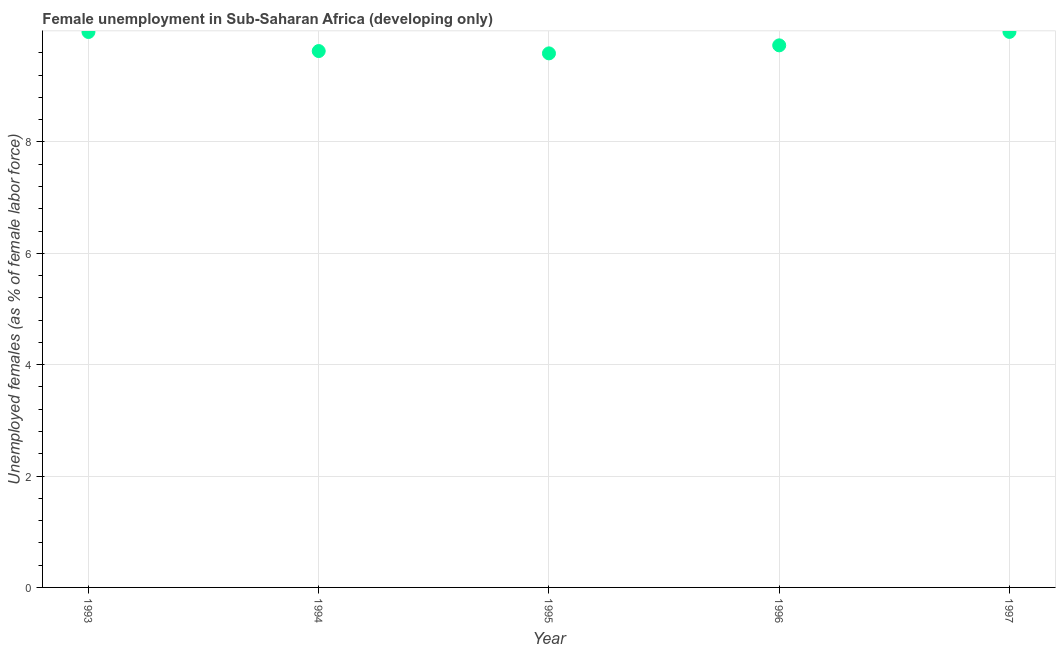What is the unemployed females population in 1993?
Your answer should be compact. 9.98. Across all years, what is the maximum unemployed females population?
Provide a short and direct response. 9.98. Across all years, what is the minimum unemployed females population?
Offer a terse response. 9.59. In which year was the unemployed females population maximum?
Give a very brief answer. 1997. What is the sum of the unemployed females population?
Make the answer very short. 48.91. What is the difference between the unemployed females population in 1994 and 1996?
Offer a terse response. -0.1. What is the average unemployed females population per year?
Keep it short and to the point. 9.78. What is the median unemployed females population?
Provide a succinct answer. 9.74. Do a majority of the years between 1994 and 1995 (inclusive) have unemployed females population greater than 6 %?
Your response must be concise. Yes. What is the ratio of the unemployed females population in 1993 to that in 1996?
Provide a short and direct response. 1.02. Is the unemployed females population in 1993 less than that in 1995?
Your answer should be compact. No. Is the difference between the unemployed females population in 1994 and 1995 greater than the difference between any two years?
Offer a very short reply. No. What is the difference between the highest and the second highest unemployed females population?
Offer a terse response. 0. What is the difference between the highest and the lowest unemployed females population?
Offer a very short reply. 0.39. Does the unemployed females population monotonically increase over the years?
Provide a succinct answer. No. What is the title of the graph?
Your answer should be compact. Female unemployment in Sub-Saharan Africa (developing only). What is the label or title of the X-axis?
Your response must be concise. Year. What is the label or title of the Y-axis?
Your answer should be compact. Unemployed females (as % of female labor force). What is the Unemployed females (as % of female labor force) in 1993?
Your answer should be very brief. 9.98. What is the Unemployed females (as % of female labor force) in 1994?
Offer a very short reply. 9.63. What is the Unemployed females (as % of female labor force) in 1995?
Give a very brief answer. 9.59. What is the Unemployed females (as % of female labor force) in 1996?
Your answer should be very brief. 9.74. What is the Unemployed females (as % of female labor force) in 1997?
Give a very brief answer. 9.98. What is the difference between the Unemployed females (as % of female labor force) in 1993 and 1994?
Offer a terse response. 0.34. What is the difference between the Unemployed females (as % of female labor force) in 1993 and 1995?
Your answer should be very brief. 0.38. What is the difference between the Unemployed females (as % of female labor force) in 1993 and 1996?
Keep it short and to the point. 0.24. What is the difference between the Unemployed females (as % of female labor force) in 1993 and 1997?
Provide a succinct answer. -0. What is the difference between the Unemployed females (as % of female labor force) in 1994 and 1995?
Make the answer very short. 0.04. What is the difference between the Unemployed females (as % of female labor force) in 1994 and 1996?
Provide a succinct answer. -0.1. What is the difference between the Unemployed females (as % of female labor force) in 1994 and 1997?
Make the answer very short. -0.34. What is the difference between the Unemployed females (as % of female labor force) in 1995 and 1996?
Give a very brief answer. -0.14. What is the difference between the Unemployed females (as % of female labor force) in 1995 and 1997?
Make the answer very short. -0.39. What is the difference between the Unemployed females (as % of female labor force) in 1996 and 1997?
Ensure brevity in your answer.  -0.24. What is the ratio of the Unemployed females (as % of female labor force) in 1993 to that in 1994?
Ensure brevity in your answer.  1.04. What is the ratio of the Unemployed females (as % of female labor force) in 1994 to that in 1996?
Keep it short and to the point. 0.99. What is the ratio of the Unemployed females (as % of female labor force) in 1994 to that in 1997?
Make the answer very short. 0.97. 